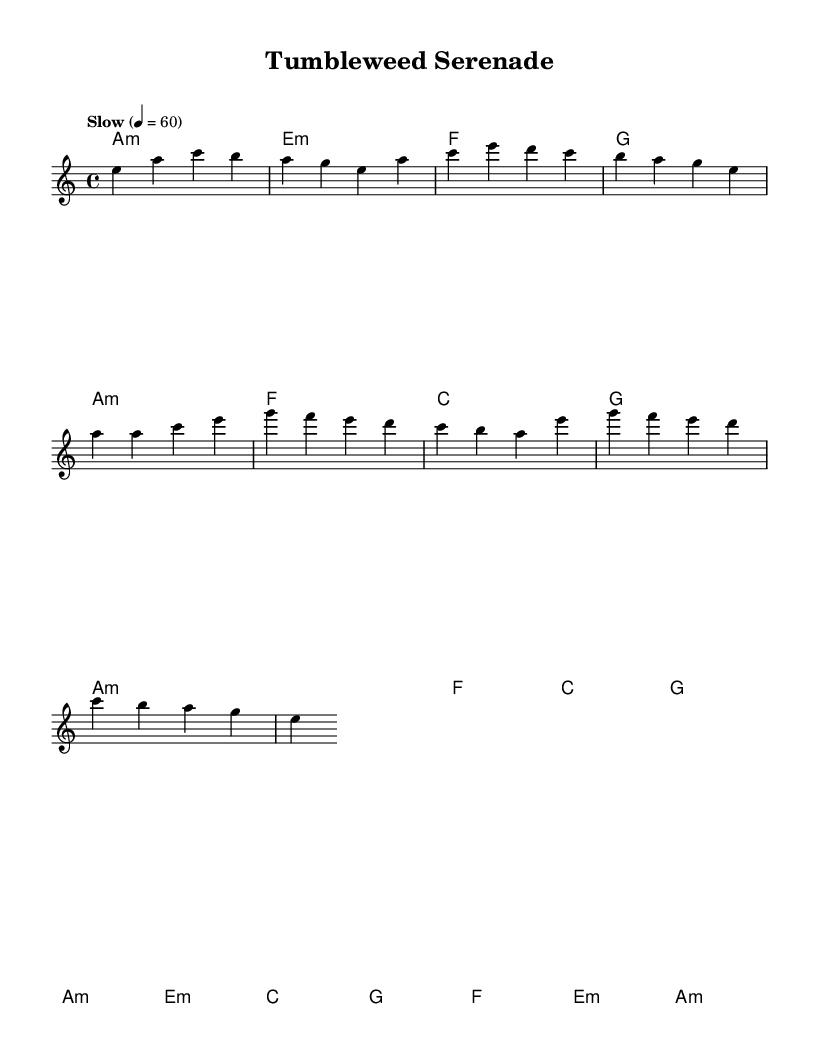What is the key signature of this music? The key signature is indicated by the key signature at the beginning of the staff, which shows one flat and identifies that the piece is in A minor.
Answer: A minor What is the time signature of the music? The time signature is shown at the beginning of the piece, represented as a fraction with four beats per measure, indicating a typical 4/4 time.
Answer: 4/4 What is the tempo marking for the piece? The tempo marking is displayed with the word "Slow" and indicates a specific speed of 60 beats per minute, determining the overall pace of the music.
Answer: Slow What chords are used in the intro? The introduction section of the sheet music clearly outlines the chords being played, specifically showing A minor, E minor, F major, and G major in sequence.
Answer: A minor, E minor, F, G What is the conclusion of the bridge section in terms of harmony? The bridge section ends with an A minor chord, which is indicated as the last chord in that part of the score, showing a strong resolution point in the progression.
Answer: A minor How many measures are in the chorus? By counting each separate line of the chorus section within the grouped music, we can see there are six measures that form this part of the tune.
Answer: 6 Which scale degrees primarily feature in the melody's opening phrase? The opening phrase of the melody showcases the notes E, A, C, B, and G, which relate to the first, fourth, sixth, and seventh degrees of the A minor scale.
Answer: E, A, C, B, G 